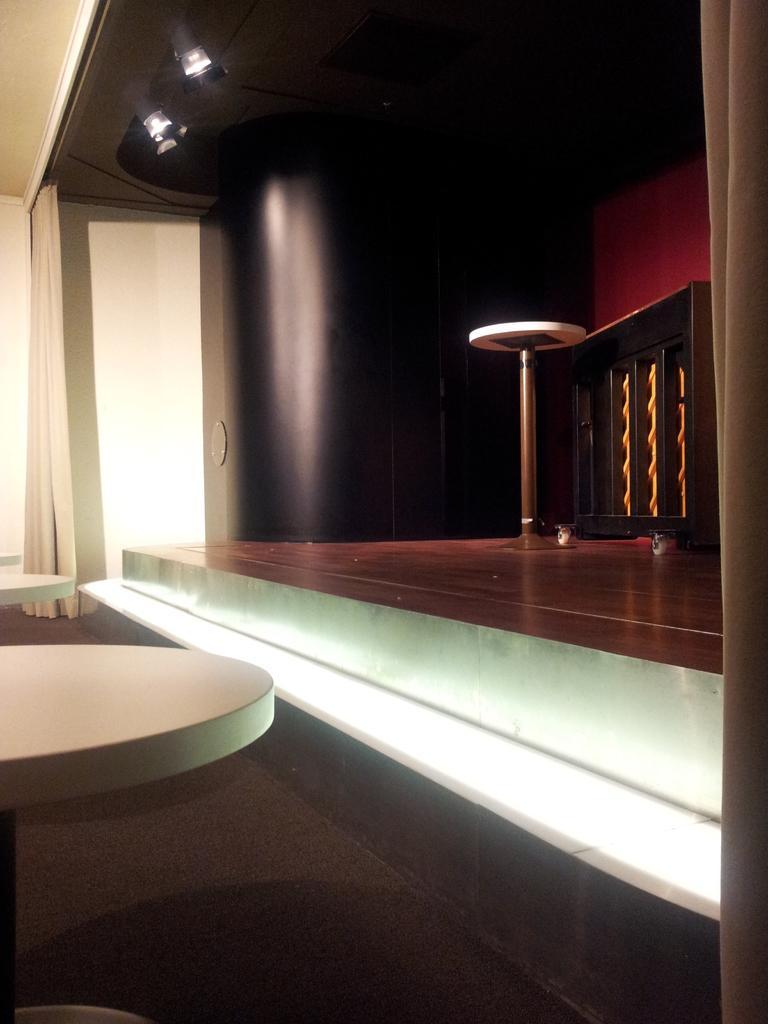Could you give a brief overview of what you see in this image? In this image we can see an inside view of a building, there are tables, curtain and lights attached to the roof. 